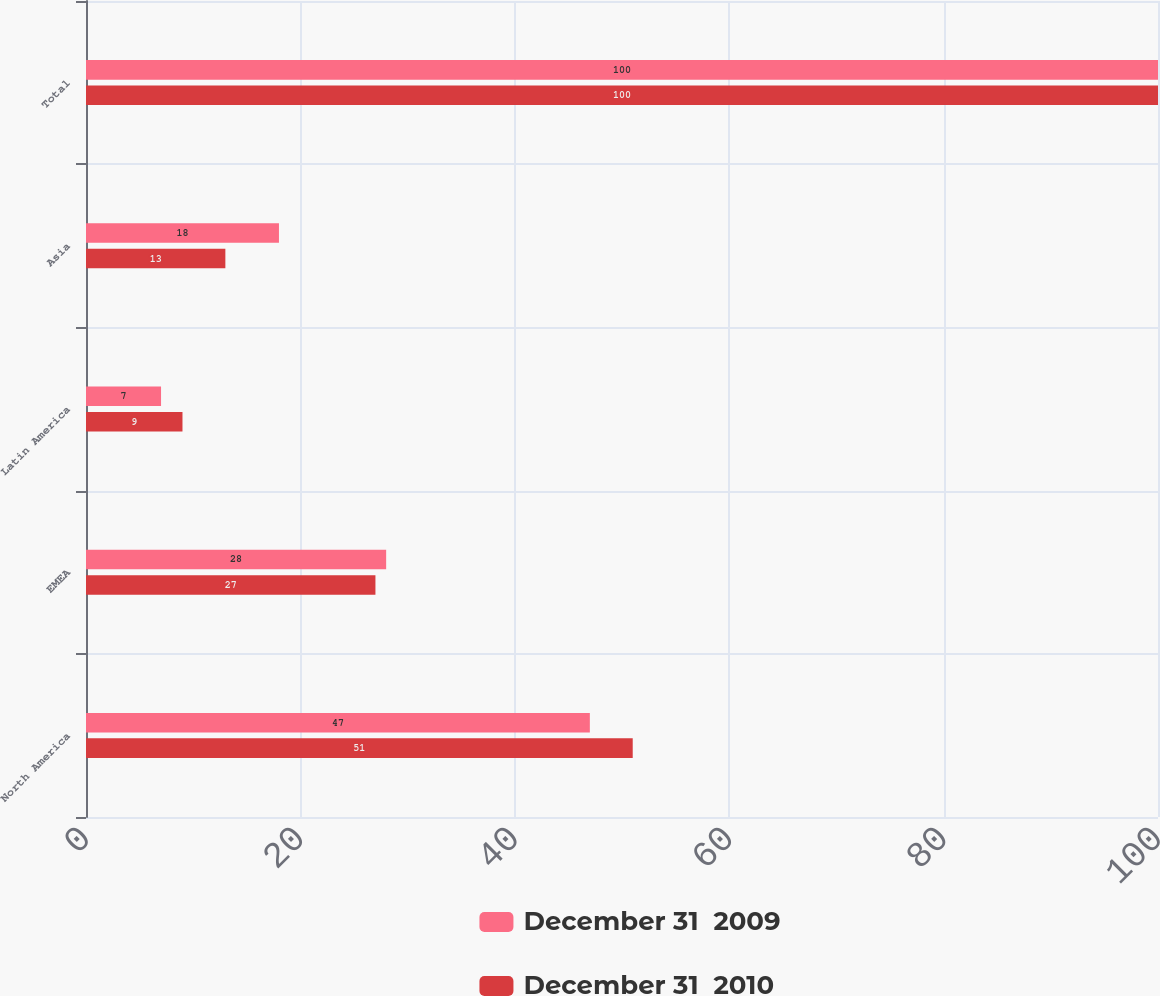Convert chart to OTSL. <chart><loc_0><loc_0><loc_500><loc_500><stacked_bar_chart><ecel><fcel>North America<fcel>EMEA<fcel>Latin America<fcel>Asia<fcel>Total<nl><fcel>December 31  2009<fcel>47<fcel>28<fcel>7<fcel>18<fcel>100<nl><fcel>December 31  2010<fcel>51<fcel>27<fcel>9<fcel>13<fcel>100<nl></chart> 